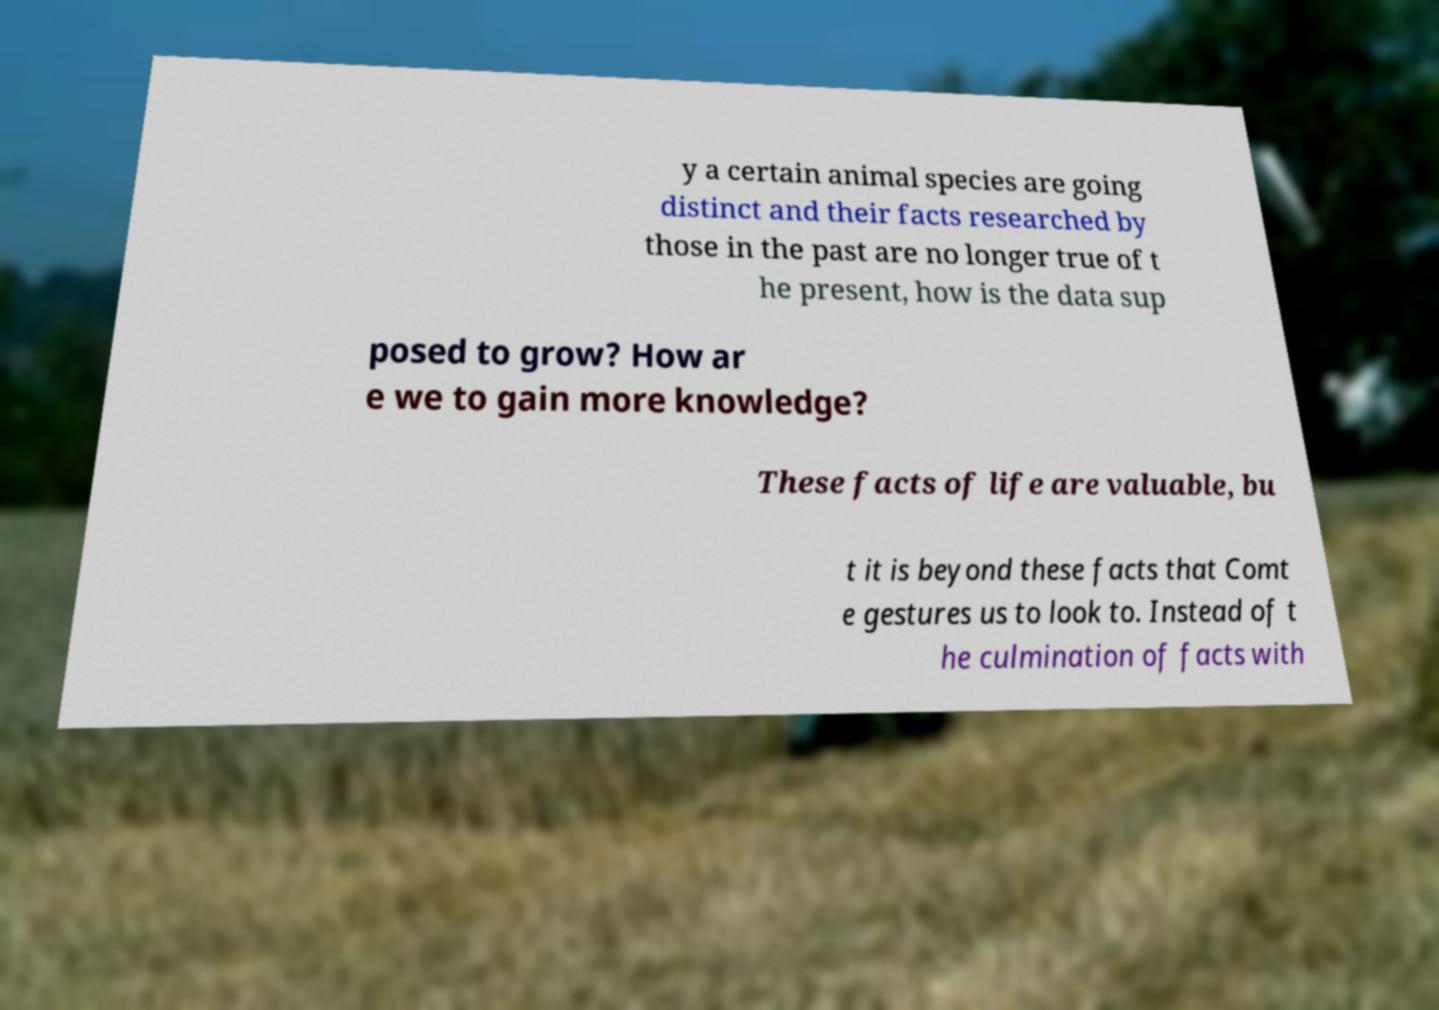Please read and relay the text visible in this image. What does it say? y a certain animal species are going distinct and their facts researched by those in the past are no longer true of t he present, how is the data sup posed to grow? How ar e we to gain more knowledge? These facts of life are valuable, bu t it is beyond these facts that Comt e gestures us to look to. Instead of t he culmination of facts with 